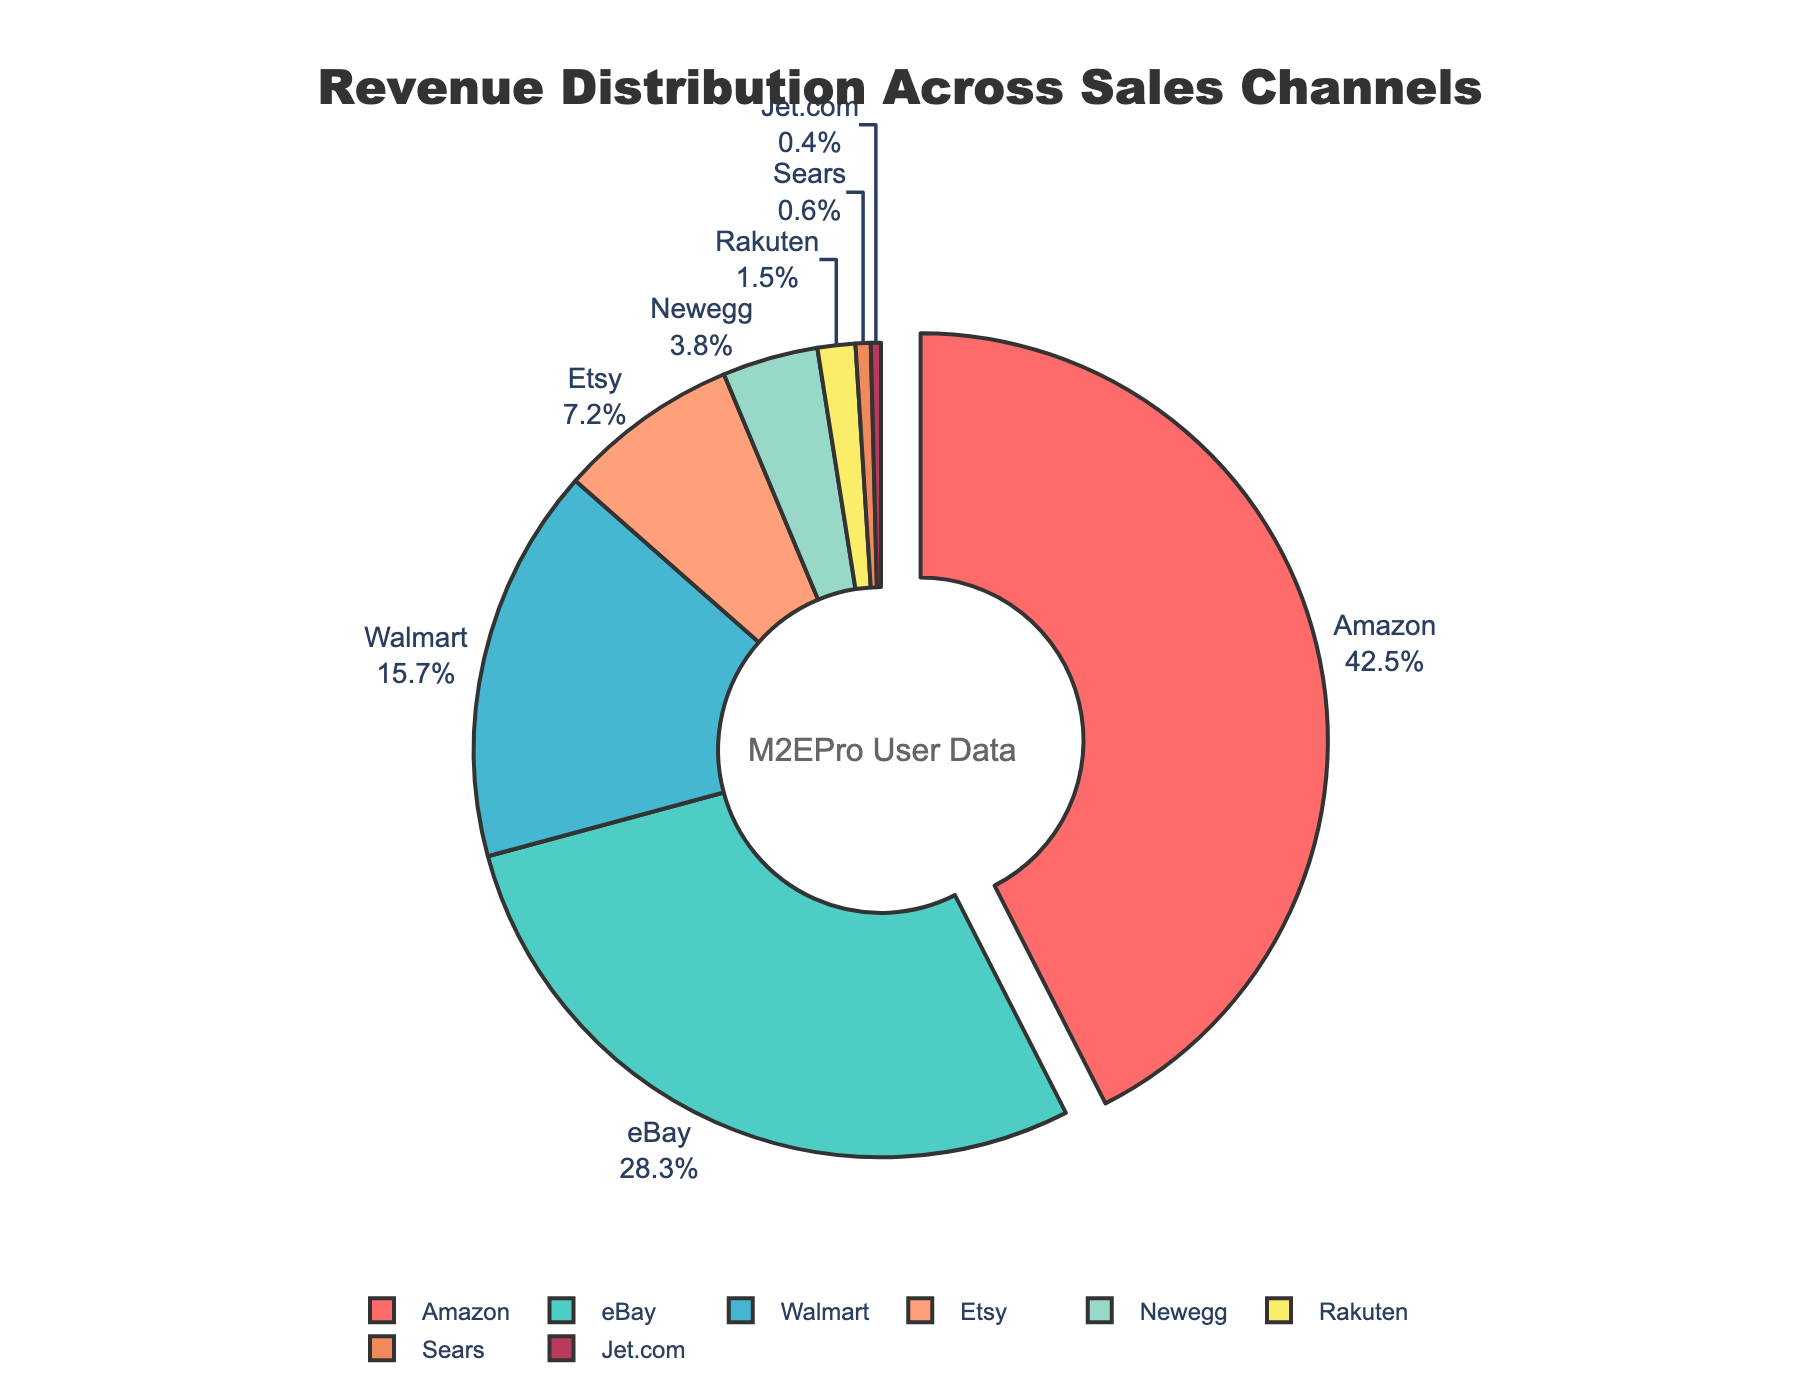What percentage of total revenue comes from channels other than Amazon? Amazon contributes 42.5% of the total revenue. Therefore, the remaining percentage is 100% - 42.5% = 57.5%.
Answer: 57.5% How does the revenue from eBay compare to that from Walmart? eBay accounts for 28.3% of the revenue, while Walmart accounts for 15.7%. Comparatively, eBay generates 12.6% more revenue than Walmart.
Answer: eBay generates more revenue Which two channels combined contribute to less revenue than Etsy alone? Etsy contributes 7.2% of the revenue. The channels contributing less than 7.2% individually are Newegg (3.8%), Rakuten (1.5%), Sears (0.6%), and Jet.com (0.4%). Combining any two of these channels, the largest sum would be Newegg (3.8%) and Rakuten (1.5%) = 5.3%, still less than 7.2%.
Answer: Newegg and Rakuten What is the sum of revenue percentages for the bottom three channels? The bottom three channels by revenue percentage are Sears (0.6%), Jet.com (0.4%), and Rakuten (1.5%). Their combined revenue is 0.6% + 0.4% + 1.5% = 2.5%.
Answer: 2.5% How many channels have a revenue percentage greater than 10%? Channels with more than 10% revenue are Amazon (42.5%), eBay (28.3%), and Walmart (15.7%).
Answer: 3 What is the difference in revenue percentage between the highest and lowest contributing channels? The highest contributing channel is Amazon at 42.5% and the lowest is Jet.com at 0.4%. The difference is 42.5% - 0.4% = 42.1%.
Answer: 42.1% Which channel is represented by the color red in the pie chart? Since the first color in the provided list of colors is red and the highest contributing channel is Amazon, Amazon would be represented by the color red.
Answer: Amazon What is the average revenue percentage among channels contributing more than 20%? The channels contributing more than 20% are Amazon (42.5%) and eBay (28.3%). Their average revenue percentage is (42.5% + 28.3%)/2 = 35.4%.
Answer: 35.4% By what percentage does the revenue of Etsy exceed that of Newegg? Etsy has 7.2% of revenue while Newegg has 3.8%. The percentage difference is 7.2% - 3.8% = 3.4%.
Answer: 3.4% 